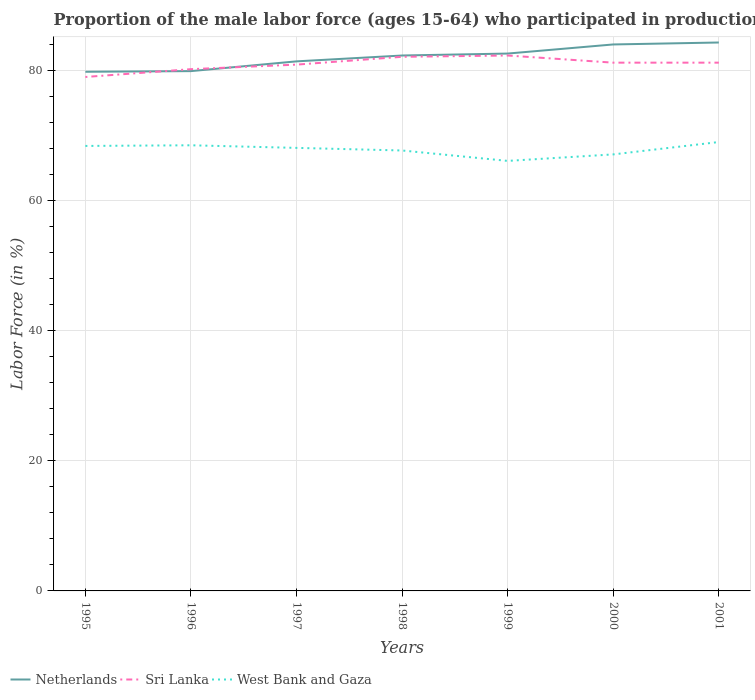How many different coloured lines are there?
Your response must be concise. 3. Across all years, what is the maximum proportion of the male labor force who participated in production in Netherlands?
Provide a short and direct response. 79.8. What is the difference between the highest and the second highest proportion of the male labor force who participated in production in Netherlands?
Provide a short and direct response. 4.5. What is the difference between the highest and the lowest proportion of the male labor force who participated in production in West Bank and Gaza?
Offer a terse response. 4. How many years are there in the graph?
Your response must be concise. 7. Are the values on the major ticks of Y-axis written in scientific E-notation?
Ensure brevity in your answer.  No. Does the graph contain grids?
Your answer should be compact. Yes. Where does the legend appear in the graph?
Provide a succinct answer. Bottom left. How are the legend labels stacked?
Ensure brevity in your answer.  Horizontal. What is the title of the graph?
Offer a terse response. Proportion of the male labor force (ages 15-64) who participated in production. What is the label or title of the Y-axis?
Keep it short and to the point. Labor Force (in %). What is the Labor Force (in %) in Netherlands in 1995?
Offer a very short reply. 79.8. What is the Labor Force (in %) in Sri Lanka in 1995?
Offer a terse response. 79. What is the Labor Force (in %) of West Bank and Gaza in 1995?
Your answer should be compact. 68.4. What is the Labor Force (in %) of Netherlands in 1996?
Provide a succinct answer. 79.9. What is the Labor Force (in %) in Sri Lanka in 1996?
Provide a short and direct response. 80.2. What is the Labor Force (in %) in West Bank and Gaza in 1996?
Offer a very short reply. 68.5. What is the Labor Force (in %) in Netherlands in 1997?
Provide a short and direct response. 81.4. What is the Labor Force (in %) in Sri Lanka in 1997?
Provide a short and direct response. 80.9. What is the Labor Force (in %) in West Bank and Gaza in 1997?
Make the answer very short. 68.1. What is the Labor Force (in %) in Netherlands in 1998?
Make the answer very short. 82.3. What is the Labor Force (in %) in Sri Lanka in 1998?
Offer a terse response. 82.1. What is the Labor Force (in %) of West Bank and Gaza in 1998?
Offer a very short reply. 67.7. What is the Labor Force (in %) of Netherlands in 1999?
Your answer should be compact. 82.6. What is the Labor Force (in %) of Sri Lanka in 1999?
Offer a terse response. 82.3. What is the Labor Force (in %) in West Bank and Gaza in 1999?
Make the answer very short. 66.1. What is the Labor Force (in %) in Sri Lanka in 2000?
Keep it short and to the point. 81.2. What is the Labor Force (in %) of West Bank and Gaza in 2000?
Your response must be concise. 67.1. What is the Labor Force (in %) of Netherlands in 2001?
Give a very brief answer. 84.3. What is the Labor Force (in %) in Sri Lanka in 2001?
Your response must be concise. 81.2. What is the Labor Force (in %) of West Bank and Gaza in 2001?
Offer a terse response. 69. Across all years, what is the maximum Labor Force (in %) in Netherlands?
Ensure brevity in your answer.  84.3. Across all years, what is the maximum Labor Force (in %) in Sri Lanka?
Give a very brief answer. 82.3. Across all years, what is the minimum Labor Force (in %) in Netherlands?
Offer a terse response. 79.8. Across all years, what is the minimum Labor Force (in %) of Sri Lanka?
Make the answer very short. 79. Across all years, what is the minimum Labor Force (in %) in West Bank and Gaza?
Give a very brief answer. 66.1. What is the total Labor Force (in %) of Netherlands in the graph?
Ensure brevity in your answer.  574.3. What is the total Labor Force (in %) in Sri Lanka in the graph?
Keep it short and to the point. 566.9. What is the total Labor Force (in %) in West Bank and Gaza in the graph?
Offer a terse response. 474.9. What is the difference between the Labor Force (in %) of Sri Lanka in 1995 and that in 1998?
Provide a succinct answer. -3.1. What is the difference between the Labor Force (in %) in West Bank and Gaza in 1995 and that in 1999?
Keep it short and to the point. 2.3. What is the difference between the Labor Force (in %) in Netherlands in 1995 and that in 2000?
Provide a succinct answer. -4.2. What is the difference between the Labor Force (in %) in Sri Lanka in 1995 and that in 2000?
Provide a succinct answer. -2.2. What is the difference between the Labor Force (in %) of Netherlands in 1995 and that in 2001?
Give a very brief answer. -4.5. What is the difference between the Labor Force (in %) in Netherlands in 1996 and that in 1997?
Keep it short and to the point. -1.5. What is the difference between the Labor Force (in %) in West Bank and Gaza in 1996 and that in 1997?
Your response must be concise. 0.4. What is the difference between the Labor Force (in %) of Sri Lanka in 1996 and that in 1998?
Offer a very short reply. -1.9. What is the difference between the Labor Force (in %) in West Bank and Gaza in 1996 and that in 1999?
Ensure brevity in your answer.  2.4. What is the difference between the Labor Force (in %) of West Bank and Gaza in 1996 and that in 2000?
Make the answer very short. 1.4. What is the difference between the Labor Force (in %) in Sri Lanka in 1996 and that in 2001?
Ensure brevity in your answer.  -1. What is the difference between the Labor Force (in %) of West Bank and Gaza in 1996 and that in 2001?
Provide a short and direct response. -0.5. What is the difference between the Labor Force (in %) of Netherlands in 1997 and that in 2000?
Give a very brief answer. -2.6. What is the difference between the Labor Force (in %) in Netherlands in 1997 and that in 2001?
Offer a terse response. -2.9. What is the difference between the Labor Force (in %) of Sri Lanka in 1997 and that in 2001?
Provide a succinct answer. -0.3. What is the difference between the Labor Force (in %) in Sri Lanka in 1998 and that in 1999?
Provide a succinct answer. -0.2. What is the difference between the Labor Force (in %) in Sri Lanka in 1999 and that in 2000?
Your answer should be compact. 1.1. What is the difference between the Labor Force (in %) in West Bank and Gaza in 1999 and that in 2000?
Offer a very short reply. -1. What is the difference between the Labor Force (in %) in Netherlands in 1995 and the Labor Force (in %) in West Bank and Gaza in 1996?
Your answer should be compact. 11.3. What is the difference between the Labor Force (in %) of Netherlands in 1995 and the Labor Force (in %) of Sri Lanka in 1997?
Keep it short and to the point. -1.1. What is the difference between the Labor Force (in %) in Sri Lanka in 1995 and the Labor Force (in %) in West Bank and Gaza in 1997?
Make the answer very short. 10.9. What is the difference between the Labor Force (in %) of Netherlands in 1995 and the Labor Force (in %) of Sri Lanka in 1998?
Your response must be concise. -2.3. What is the difference between the Labor Force (in %) of Sri Lanka in 1995 and the Labor Force (in %) of West Bank and Gaza in 1998?
Offer a very short reply. 11.3. What is the difference between the Labor Force (in %) in Sri Lanka in 1995 and the Labor Force (in %) in West Bank and Gaza in 1999?
Make the answer very short. 12.9. What is the difference between the Labor Force (in %) in Netherlands in 1995 and the Labor Force (in %) in Sri Lanka in 2000?
Your response must be concise. -1.4. What is the difference between the Labor Force (in %) of Netherlands in 1995 and the Labor Force (in %) of Sri Lanka in 2001?
Provide a succinct answer. -1.4. What is the difference between the Labor Force (in %) of Netherlands in 1995 and the Labor Force (in %) of West Bank and Gaza in 2001?
Ensure brevity in your answer.  10.8. What is the difference between the Labor Force (in %) in Netherlands in 1996 and the Labor Force (in %) in Sri Lanka in 1997?
Keep it short and to the point. -1. What is the difference between the Labor Force (in %) in Netherlands in 1996 and the Labor Force (in %) in West Bank and Gaza in 1998?
Ensure brevity in your answer.  12.2. What is the difference between the Labor Force (in %) in Sri Lanka in 1996 and the Labor Force (in %) in West Bank and Gaza in 1998?
Give a very brief answer. 12.5. What is the difference between the Labor Force (in %) of Netherlands in 1996 and the Labor Force (in %) of Sri Lanka in 1999?
Give a very brief answer. -2.4. What is the difference between the Labor Force (in %) of Netherlands in 1996 and the Labor Force (in %) of Sri Lanka in 2000?
Make the answer very short. -1.3. What is the difference between the Labor Force (in %) of Sri Lanka in 1996 and the Labor Force (in %) of West Bank and Gaza in 2000?
Offer a very short reply. 13.1. What is the difference between the Labor Force (in %) in Netherlands in 1996 and the Labor Force (in %) in West Bank and Gaza in 2001?
Offer a very short reply. 10.9. What is the difference between the Labor Force (in %) of Netherlands in 1997 and the Labor Force (in %) of West Bank and Gaza in 1998?
Provide a short and direct response. 13.7. What is the difference between the Labor Force (in %) of Netherlands in 1997 and the Labor Force (in %) of Sri Lanka in 1999?
Your answer should be very brief. -0.9. What is the difference between the Labor Force (in %) in Sri Lanka in 1997 and the Labor Force (in %) in West Bank and Gaza in 1999?
Offer a terse response. 14.8. What is the difference between the Labor Force (in %) in Netherlands in 1997 and the Labor Force (in %) in Sri Lanka in 2001?
Make the answer very short. 0.2. What is the difference between the Labor Force (in %) of Netherlands in 1998 and the Labor Force (in %) of West Bank and Gaza in 1999?
Your response must be concise. 16.2. What is the difference between the Labor Force (in %) in Sri Lanka in 1998 and the Labor Force (in %) in West Bank and Gaza in 1999?
Your answer should be compact. 16. What is the difference between the Labor Force (in %) in Netherlands in 1998 and the Labor Force (in %) in Sri Lanka in 2000?
Offer a terse response. 1.1. What is the difference between the Labor Force (in %) of Netherlands in 1998 and the Labor Force (in %) of West Bank and Gaza in 2001?
Make the answer very short. 13.3. What is the difference between the Labor Force (in %) in Sri Lanka in 1999 and the Labor Force (in %) in West Bank and Gaza in 2001?
Offer a very short reply. 13.3. What is the difference between the Labor Force (in %) of Netherlands in 2000 and the Labor Force (in %) of Sri Lanka in 2001?
Offer a very short reply. 2.8. What is the difference between the Labor Force (in %) of Sri Lanka in 2000 and the Labor Force (in %) of West Bank and Gaza in 2001?
Make the answer very short. 12.2. What is the average Labor Force (in %) in Netherlands per year?
Ensure brevity in your answer.  82.04. What is the average Labor Force (in %) of Sri Lanka per year?
Offer a very short reply. 80.99. What is the average Labor Force (in %) of West Bank and Gaza per year?
Provide a short and direct response. 67.84. In the year 1995, what is the difference between the Labor Force (in %) of Sri Lanka and Labor Force (in %) of West Bank and Gaza?
Ensure brevity in your answer.  10.6. In the year 1996, what is the difference between the Labor Force (in %) of Sri Lanka and Labor Force (in %) of West Bank and Gaza?
Your answer should be very brief. 11.7. In the year 1997, what is the difference between the Labor Force (in %) of Netherlands and Labor Force (in %) of Sri Lanka?
Provide a short and direct response. 0.5. In the year 1997, what is the difference between the Labor Force (in %) of Sri Lanka and Labor Force (in %) of West Bank and Gaza?
Offer a very short reply. 12.8. In the year 1998, what is the difference between the Labor Force (in %) of Netherlands and Labor Force (in %) of West Bank and Gaza?
Ensure brevity in your answer.  14.6. In the year 1999, what is the difference between the Labor Force (in %) in Netherlands and Labor Force (in %) in Sri Lanka?
Offer a terse response. 0.3. In the year 1999, what is the difference between the Labor Force (in %) of Sri Lanka and Labor Force (in %) of West Bank and Gaza?
Your answer should be compact. 16.2. In the year 2000, what is the difference between the Labor Force (in %) of Netherlands and Labor Force (in %) of West Bank and Gaza?
Your response must be concise. 16.9. In the year 2001, what is the difference between the Labor Force (in %) in Sri Lanka and Labor Force (in %) in West Bank and Gaza?
Provide a short and direct response. 12.2. What is the ratio of the Labor Force (in %) of Netherlands in 1995 to that in 1997?
Ensure brevity in your answer.  0.98. What is the ratio of the Labor Force (in %) of Sri Lanka in 1995 to that in 1997?
Keep it short and to the point. 0.98. What is the ratio of the Labor Force (in %) of Netherlands in 1995 to that in 1998?
Provide a short and direct response. 0.97. What is the ratio of the Labor Force (in %) in Sri Lanka in 1995 to that in 1998?
Your answer should be compact. 0.96. What is the ratio of the Labor Force (in %) in West Bank and Gaza in 1995 to that in 1998?
Your answer should be very brief. 1.01. What is the ratio of the Labor Force (in %) in Netherlands in 1995 to that in 1999?
Offer a very short reply. 0.97. What is the ratio of the Labor Force (in %) in Sri Lanka in 1995 to that in 1999?
Your response must be concise. 0.96. What is the ratio of the Labor Force (in %) in West Bank and Gaza in 1995 to that in 1999?
Give a very brief answer. 1.03. What is the ratio of the Labor Force (in %) in Netherlands in 1995 to that in 2000?
Offer a very short reply. 0.95. What is the ratio of the Labor Force (in %) of Sri Lanka in 1995 to that in 2000?
Offer a very short reply. 0.97. What is the ratio of the Labor Force (in %) in West Bank and Gaza in 1995 to that in 2000?
Offer a very short reply. 1.02. What is the ratio of the Labor Force (in %) of Netherlands in 1995 to that in 2001?
Your answer should be compact. 0.95. What is the ratio of the Labor Force (in %) in Sri Lanka in 1995 to that in 2001?
Provide a short and direct response. 0.97. What is the ratio of the Labor Force (in %) of West Bank and Gaza in 1995 to that in 2001?
Keep it short and to the point. 0.99. What is the ratio of the Labor Force (in %) in Netherlands in 1996 to that in 1997?
Offer a terse response. 0.98. What is the ratio of the Labor Force (in %) of Sri Lanka in 1996 to that in 1997?
Your response must be concise. 0.99. What is the ratio of the Labor Force (in %) in West Bank and Gaza in 1996 to that in 1997?
Ensure brevity in your answer.  1.01. What is the ratio of the Labor Force (in %) of Netherlands in 1996 to that in 1998?
Offer a very short reply. 0.97. What is the ratio of the Labor Force (in %) in Sri Lanka in 1996 to that in 1998?
Make the answer very short. 0.98. What is the ratio of the Labor Force (in %) in West Bank and Gaza in 1996 to that in 1998?
Ensure brevity in your answer.  1.01. What is the ratio of the Labor Force (in %) in Netherlands in 1996 to that in 1999?
Give a very brief answer. 0.97. What is the ratio of the Labor Force (in %) in Sri Lanka in 1996 to that in 1999?
Provide a succinct answer. 0.97. What is the ratio of the Labor Force (in %) of West Bank and Gaza in 1996 to that in 1999?
Offer a very short reply. 1.04. What is the ratio of the Labor Force (in %) of Netherlands in 1996 to that in 2000?
Your answer should be very brief. 0.95. What is the ratio of the Labor Force (in %) of Sri Lanka in 1996 to that in 2000?
Keep it short and to the point. 0.99. What is the ratio of the Labor Force (in %) in West Bank and Gaza in 1996 to that in 2000?
Make the answer very short. 1.02. What is the ratio of the Labor Force (in %) of Netherlands in 1996 to that in 2001?
Provide a short and direct response. 0.95. What is the ratio of the Labor Force (in %) of Sri Lanka in 1997 to that in 1998?
Your answer should be compact. 0.99. What is the ratio of the Labor Force (in %) in West Bank and Gaza in 1997 to that in 1998?
Keep it short and to the point. 1.01. What is the ratio of the Labor Force (in %) of Netherlands in 1997 to that in 1999?
Provide a succinct answer. 0.99. What is the ratio of the Labor Force (in %) of Sri Lanka in 1997 to that in 1999?
Provide a short and direct response. 0.98. What is the ratio of the Labor Force (in %) of West Bank and Gaza in 1997 to that in 1999?
Offer a very short reply. 1.03. What is the ratio of the Labor Force (in %) in Sri Lanka in 1997 to that in 2000?
Your answer should be very brief. 1. What is the ratio of the Labor Force (in %) of West Bank and Gaza in 1997 to that in 2000?
Offer a very short reply. 1.01. What is the ratio of the Labor Force (in %) in Netherlands in 1997 to that in 2001?
Offer a terse response. 0.97. What is the ratio of the Labor Force (in %) of West Bank and Gaza in 1997 to that in 2001?
Keep it short and to the point. 0.99. What is the ratio of the Labor Force (in %) in West Bank and Gaza in 1998 to that in 1999?
Give a very brief answer. 1.02. What is the ratio of the Labor Force (in %) of Netherlands in 1998 to that in 2000?
Your answer should be very brief. 0.98. What is the ratio of the Labor Force (in %) of Sri Lanka in 1998 to that in 2000?
Your answer should be very brief. 1.01. What is the ratio of the Labor Force (in %) in West Bank and Gaza in 1998 to that in 2000?
Offer a very short reply. 1.01. What is the ratio of the Labor Force (in %) of Netherlands in 1998 to that in 2001?
Ensure brevity in your answer.  0.98. What is the ratio of the Labor Force (in %) in Sri Lanka in 1998 to that in 2001?
Provide a succinct answer. 1.01. What is the ratio of the Labor Force (in %) of West Bank and Gaza in 1998 to that in 2001?
Make the answer very short. 0.98. What is the ratio of the Labor Force (in %) in Netherlands in 1999 to that in 2000?
Keep it short and to the point. 0.98. What is the ratio of the Labor Force (in %) in Sri Lanka in 1999 to that in 2000?
Offer a very short reply. 1.01. What is the ratio of the Labor Force (in %) in West Bank and Gaza in 1999 to that in 2000?
Provide a succinct answer. 0.99. What is the ratio of the Labor Force (in %) in Netherlands in 1999 to that in 2001?
Keep it short and to the point. 0.98. What is the ratio of the Labor Force (in %) in Sri Lanka in 1999 to that in 2001?
Provide a succinct answer. 1.01. What is the ratio of the Labor Force (in %) of West Bank and Gaza in 1999 to that in 2001?
Your response must be concise. 0.96. What is the ratio of the Labor Force (in %) of Netherlands in 2000 to that in 2001?
Give a very brief answer. 1. What is the ratio of the Labor Force (in %) in West Bank and Gaza in 2000 to that in 2001?
Keep it short and to the point. 0.97. What is the difference between the highest and the lowest Labor Force (in %) in West Bank and Gaza?
Keep it short and to the point. 2.9. 